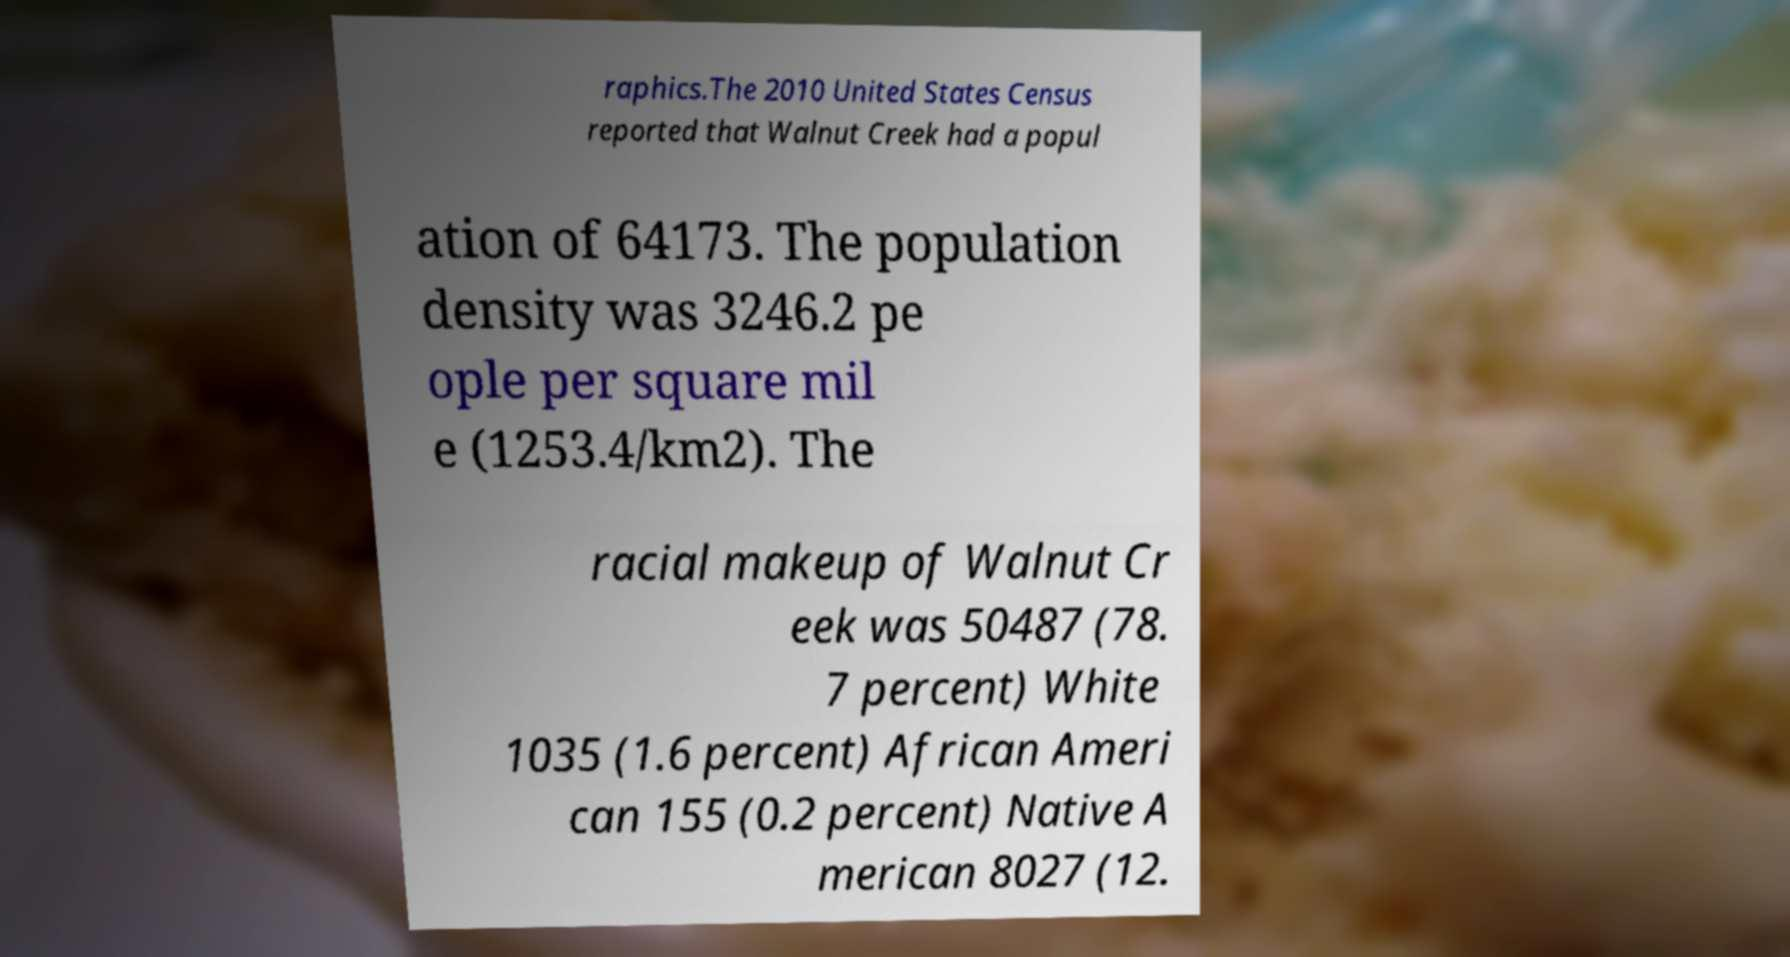Could you extract and type out the text from this image? raphics.The 2010 United States Census reported that Walnut Creek had a popul ation of 64173. The population density was 3246.2 pe ople per square mil e (1253.4/km2). The racial makeup of Walnut Cr eek was 50487 (78. 7 percent) White 1035 (1.6 percent) African Ameri can 155 (0.2 percent) Native A merican 8027 (12. 